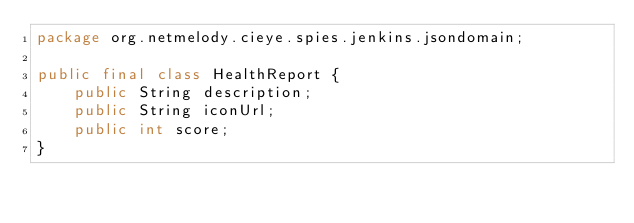<code> <loc_0><loc_0><loc_500><loc_500><_Java_>package org.netmelody.cieye.spies.jenkins.jsondomain;

public final class HealthReport {
    public String description;
    public String iconUrl;
    public int score;
}</code> 